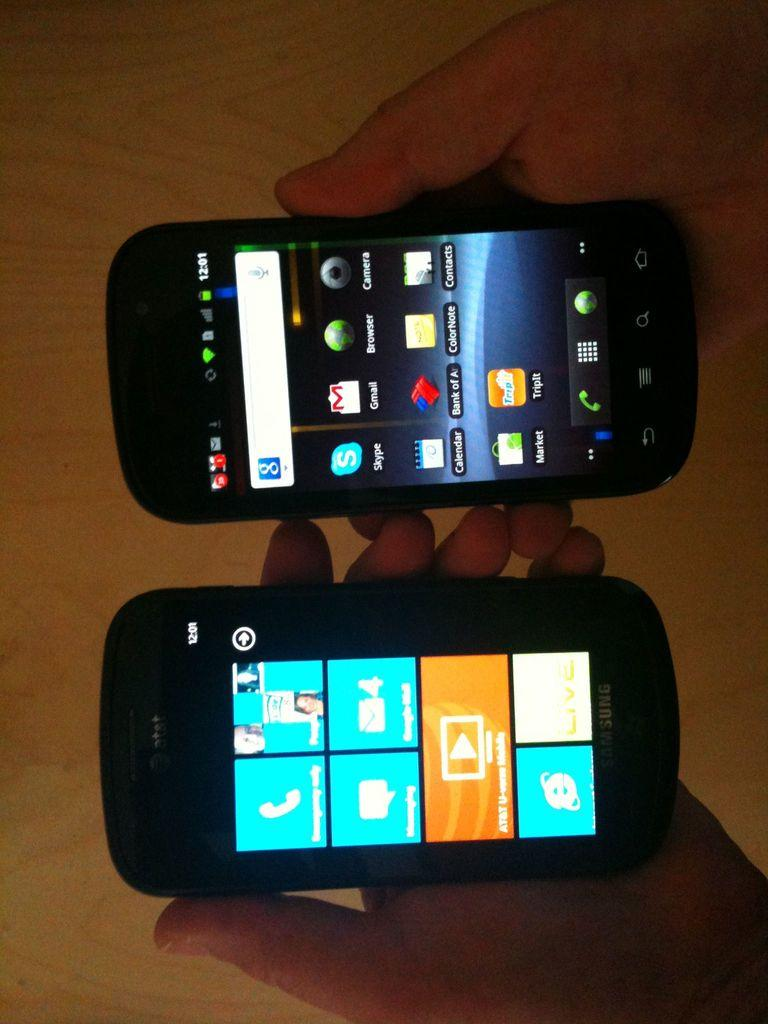Provide a one-sentence caption for the provided image. A person holds two cell phones in their hands and they both show the same time. 